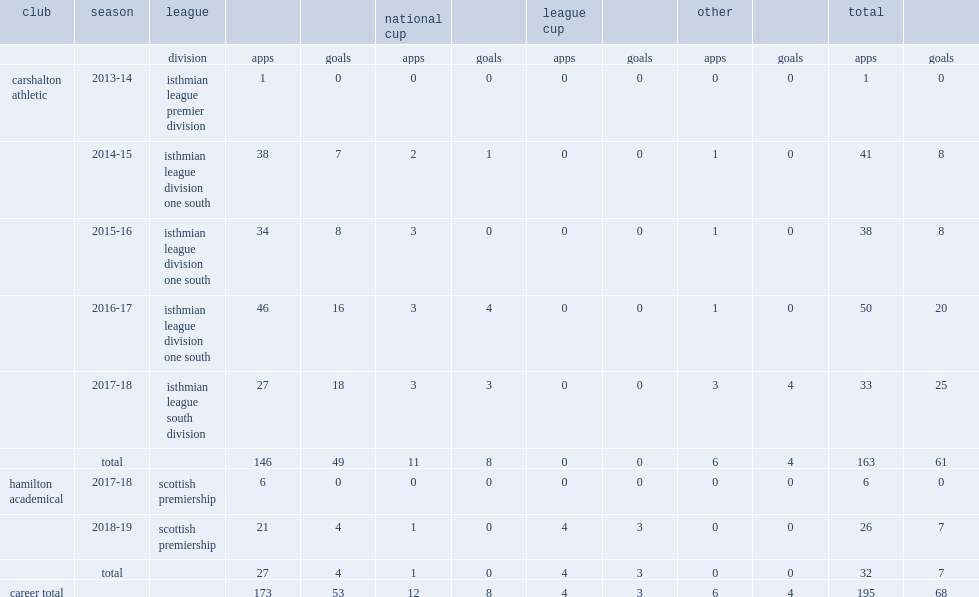Which division did miller play in the 2013-14 season? Isthmian league premier division. 